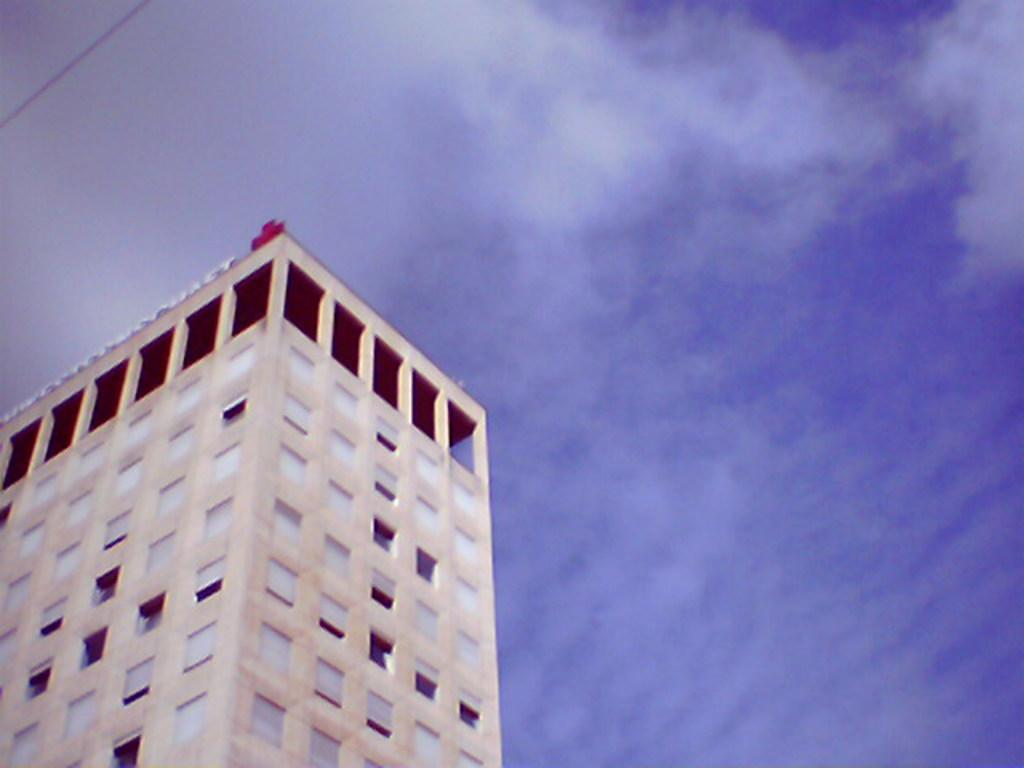What is the main structure visible in the image? There is a building in the image. Can you describe any specific details about the building? Unfortunately, the provided facts do not mention any specific details about the building. What can be seen in the top left corner of the image? There is a black color thing in the top left of the image. What is visible in the background of the image? The sky is visible in the background of the image. What type of watch is the building wearing in the image? There is no watch present in the image, as the main subject is a building. 